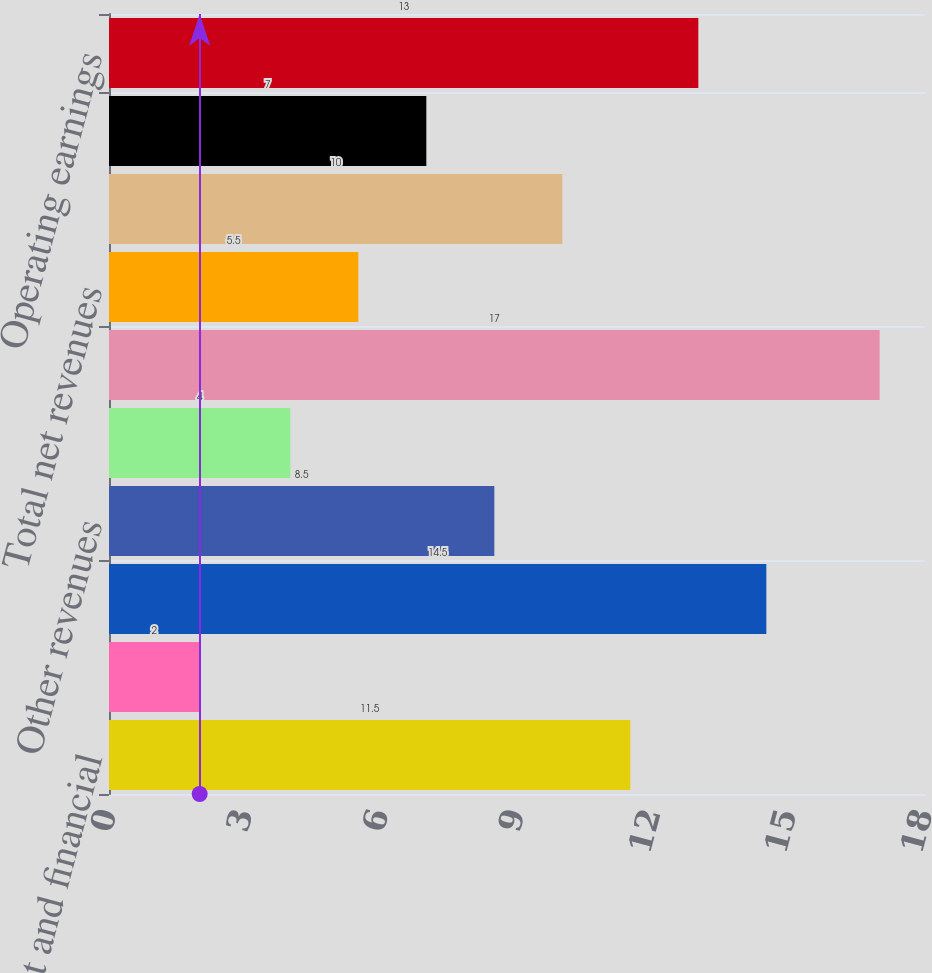Convert chart to OTSL. <chart><loc_0><loc_0><loc_500><loc_500><bar_chart><fcel>Management and financial<fcel>Distribution fees<fcel>Net investment income<fcel>Other revenues<fcel>Total revenues<fcel>Banking and deposit interest<fcel>Total net revenues<fcel>Distribution expenses<fcel>Total expenses<fcel>Operating earnings<nl><fcel>11.5<fcel>2<fcel>14.5<fcel>8.5<fcel>4<fcel>17<fcel>5.5<fcel>10<fcel>7<fcel>13<nl></chart> 